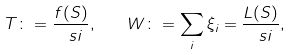Convert formula to latex. <formula><loc_0><loc_0><loc_500><loc_500>T \colon = \frac { f ( S ) } { \ s i } , \quad W \colon = \sum _ { i } \xi _ { i } = \frac { L ( S ) } { \ s i } ,</formula> 